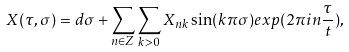<formula> <loc_0><loc_0><loc_500><loc_500>X ( \tau , \sigma ) = d \sigma + \sum _ { n \in Z } \sum _ { k > 0 } X _ { n k } \sin ( k \pi \sigma ) e x p ( 2 \pi i n \frac { \tau } { t } ) ,</formula> 